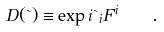Convert formula to latex. <formula><loc_0><loc_0><loc_500><loc_500>D ( \theta ) \equiv \exp { i \theta _ { i } F ^ { i } } \quad .</formula> 